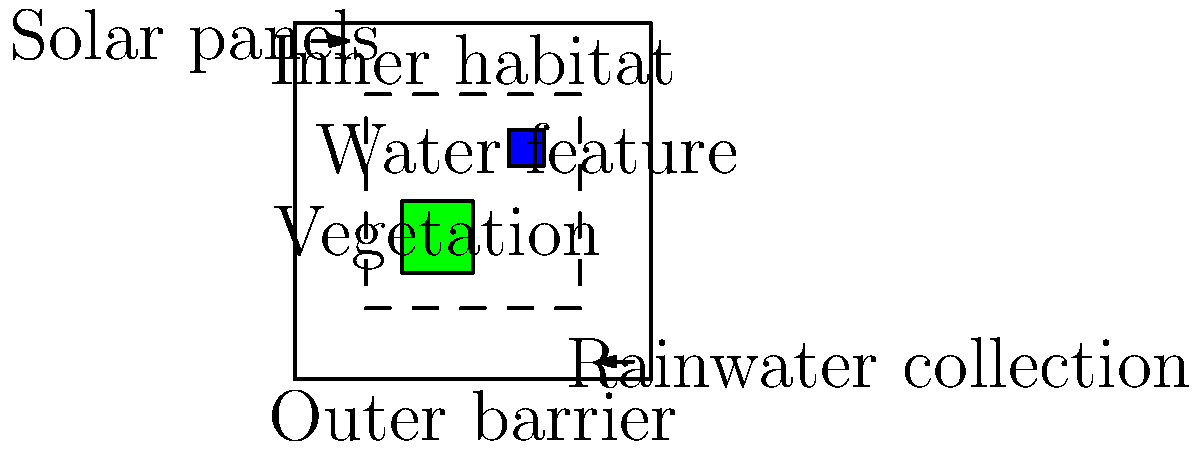In designing a sustainable and eco-friendly zoo enclosure for large mammals, which of the following features would be most effective in minimizing water consumption while maintaining animal welfare?

A) Artificial turf throughout the enclosure
B) A closed-loop water recycling system
C) Daily pressure washing of surfaces
D) Concrete flooring for easy cleaning To answer this question, let's consider each option from the perspective of water conservation and animal welfare:

1. Artificial turf:
   - Pros: Requires no watering
   - Cons: Not natural for animals, can get hot, may contain harmful chemicals

2. Closed-loop water recycling system:
   - Pros: Significantly reduces water consumption, mimics natural water cycles
   - Cons: Initial setup cost, but long-term benefits outweigh this

3. Daily pressure washing:
   - Pros: Maintains cleanliness
   - Cons: Extremely water-intensive, not necessary for animal welfare

4. Concrete flooring:
   - Pros: Easy to clean with less water
   - Cons: Unnatural for animals, can cause joint problems, lacks enrichment

Considering both water conservation and animal welfare, a closed-loop water recycling system (option B) is the most effective solution. It dramatically reduces water consumption by treating and reusing water within the enclosure. This system can be used for various purposes, including:

1. Maintaining water features that animals can drink from or play in
2. Irrigating natural vegetation within the enclosure
3. Cleaning the enclosure when necessary

Additionally, a closed-loop system mimics natural water cycles, providing a more authentic environment for the animals. It also allows for the integration of filtration systems that can remove contaminants, ensuring the water remains clean and safe for the animals.

While the initial setup cost may be higher, the long-term benefits in terms of water conservation and reduced operational costs make it the most sustainable option. It also aligns with the persona's concern for animal welfare by providing a more natural and enriching environment.
Answer: B) A closed-loop water recycling system 